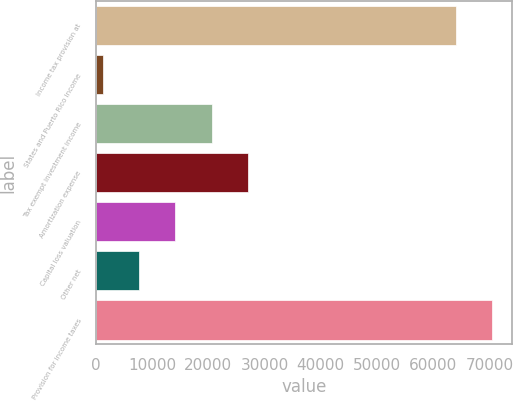Convert chart to OTSL. <chart><loc_0><loc_0><loc_500><loc_500><bar_chart><fcel>Income tax provision at<fcel>States and Puerto Rico income<fcel>Tax exempt investment income<fcel>Amortization expense<fcel>Capital loss valuation<fcel>Other net<fcel>Provision for income taxes<nl><fcel>64078<fcel>1225<fcel>20630.2<fcel>27098.6<fcel>14161.8<fcel>7693.4<fcel>70546.4<nl></chart> 